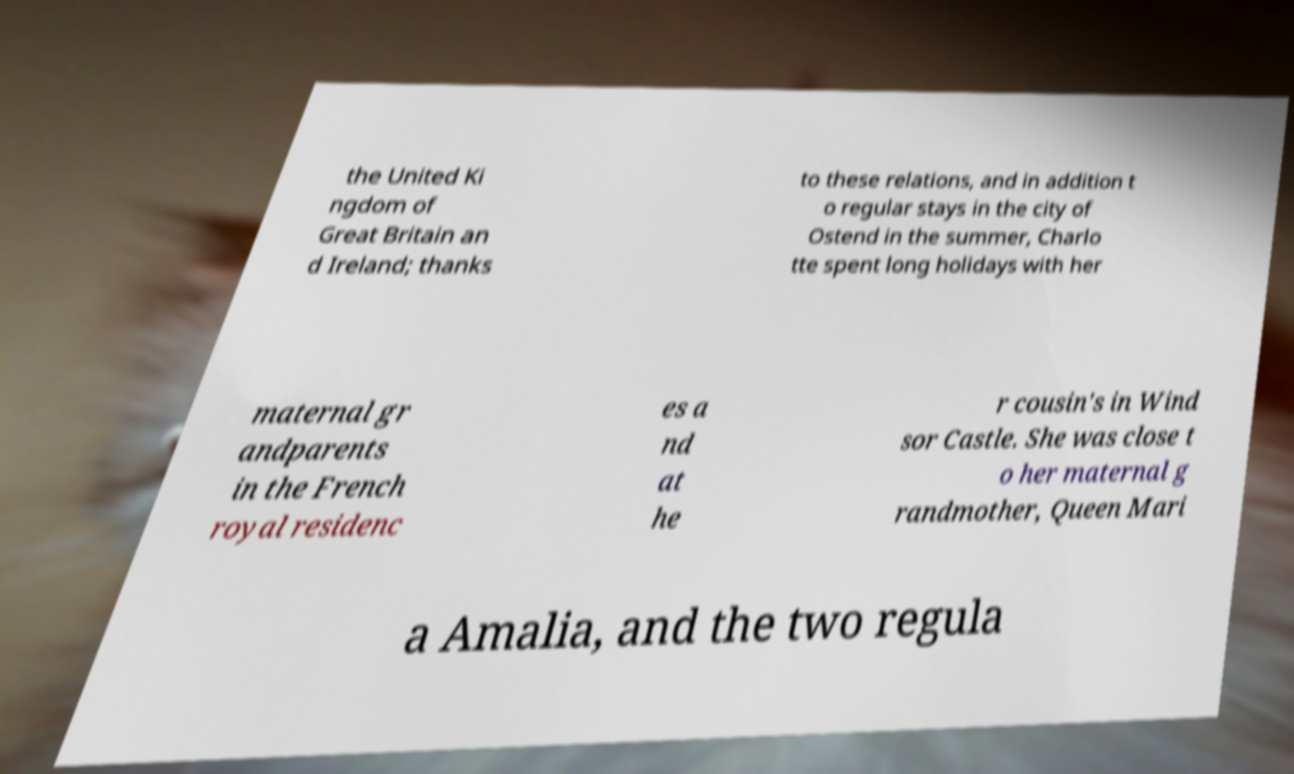Can you read and provide the text displayed in the image?This photo seems to have some interesting text. Can you extract and type it out for me? the United Ki ngdom of Great Britain an d Ireland; thanks to these relations, and in addition t o regular stays in the city of Ostend in the summer, Charlo tte spent long holidays with her maternal gr andparents in the French royal residenc es a nd at he r cousin's in Wind sor Castle. She was close t o her maternal g randmother, Queen Mari a Amalia, and the two regula 